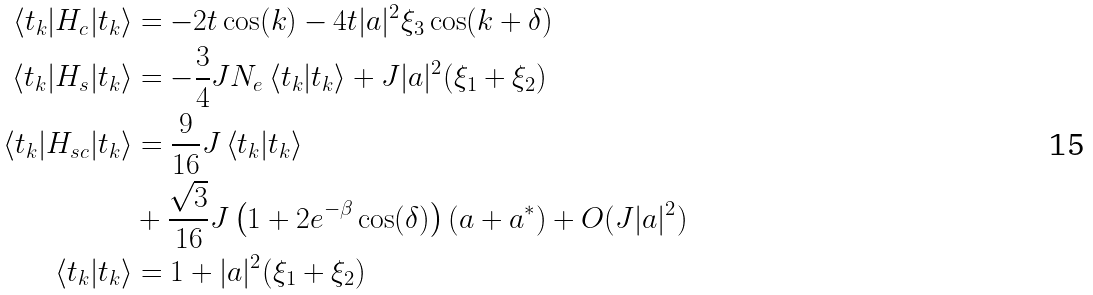<formula> <loc_0><loc_0><loc_500><loc_500>\left < t _ { k } | H _ { c } | t _ { k } \right > & = - 2 t \cos ( k ) - 4 t | a | ^ { 2 } \xi _ { 3 } \cos ( k + \delta ) \\ \left < t _ { k } | H _ { s } | t _ { k } \right > & = - \frac { 3 } { 4 } J N _ { e } \left < t _ { k } | t _ { k } \right > + J | a | ^ { 2 } ( \xi _ { 1 } + \xi _ { 2 } ) \\ \left < t _ { k } | H _ { s c } | t _ { k } \right > & = \frac { 9 } { 1 6 } J \left < t _ { k } | t _ { k } \right > \\ & + \frac { \sqrt { 3 } } { 1 6 } J \left ( 1 + 2 e ^ { - \beta } \cos ( \delta ) \right ) ( a + a ^ { * } ) + O ( J | a | ^ { 2 } ) \\ \left < t _ { k } | t _ { k } \right > & = 1 + | a | ^ { 2 } ( \xi _ { 1 } + \xi _ { 2 } )</formula> 